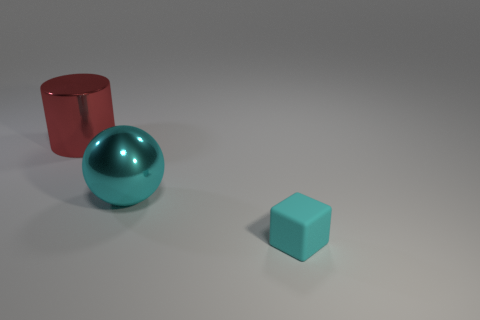There is a large thing that is in front of the large red metallic thing; how many cylinders are in front of it?
Make the answer very short. 0. How many big cyan objects are made of the same material as the tiny block?
Ensure brevity in your answer.  0. There is a big cylinder; are there any big red metallic cylinders to the left of it?
Offer a terse response. No. The metallic object that is the same size as the shiny cylinder is what color?
Offer a very short reply. Cyan. How many objects are large metal things that are behind the cyan ball or big green metallic cubes?
Make the answer very short. 1. There is a object that is both in front of the red object and behind the small cyan matte cube; what is its size?
Your answer should be very brief. Large. What size is the matte thing that is the same color as the big ball?
Offer a very short reply. Small. What number of other objects are there of the same size as the cyan shiny thing?
Ensure brevity in your answer.  1. There is a large thing right of the big thing on the left side of the metallic thing on the right side of the red thing; what is its color?
Your answer should be very brief. Cyan. How many other things are the same shape as the cyan metal object?
Your answer should be compact. 0. 